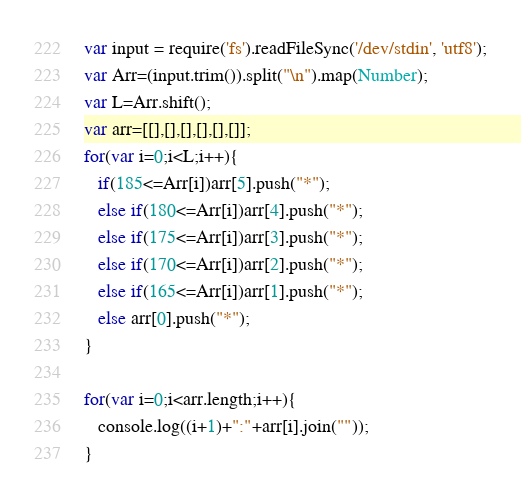Convert code to text. <code><loc_0><loc_0><loc_500><loc_500><_JavaScript_>var input = require('fs').readFileSync('/dev/stdin', 'utf8');
var Arr=(input.trim()).split("\n").map(Number);
var L=Arr.shift();
var arr=[[],[],[],[],[],[]];
for(var i=0;i<L;i++){
   if(185<=Arr[i])arr[5].push("*");
   else if(180<=Arr[i])arr[4].push("*");
   else if(175<=Arr[i])arr[3].push("*");
   else if(170<=Arr[i])arr[2].push("*");
   else if(165<=Arr[i])arr[1].push("*");
   else arr[0].push("*");
}

for(var i=0;i<arr.length;i++){
   console.log((i+1)+":"+arr[i].join(""));
}</code> 